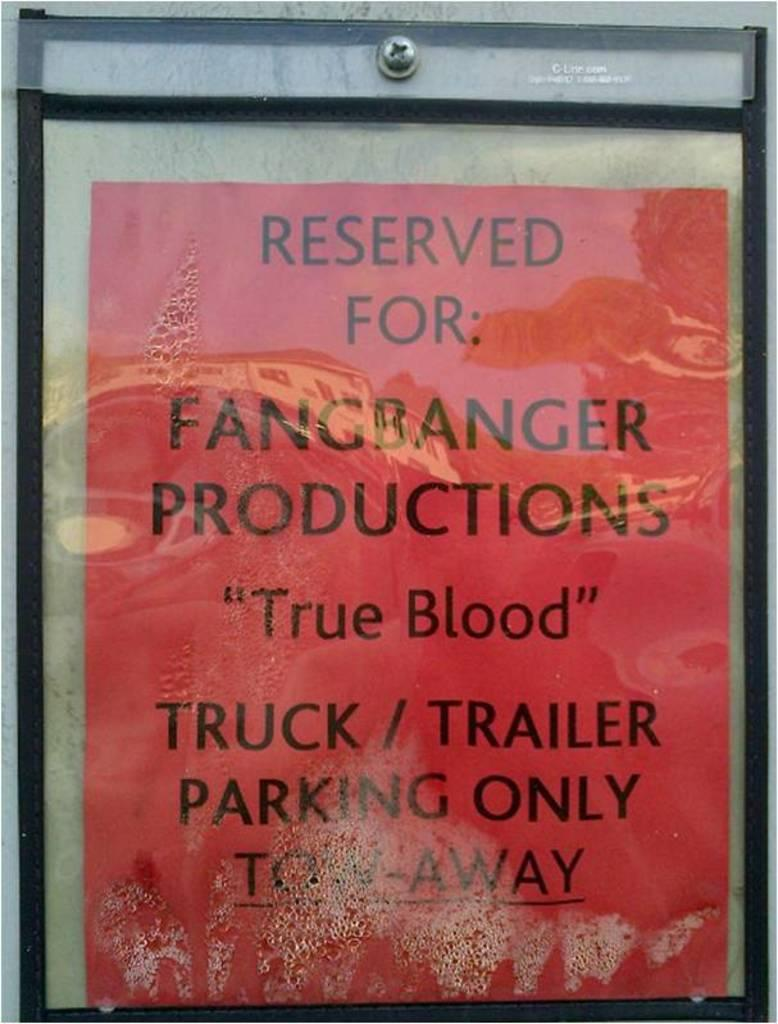<image>
Render a clear and concise summary of the photo. A red sign reserving parking for Fangbabger Productions threatens unauthorized vehicles may be towed. 